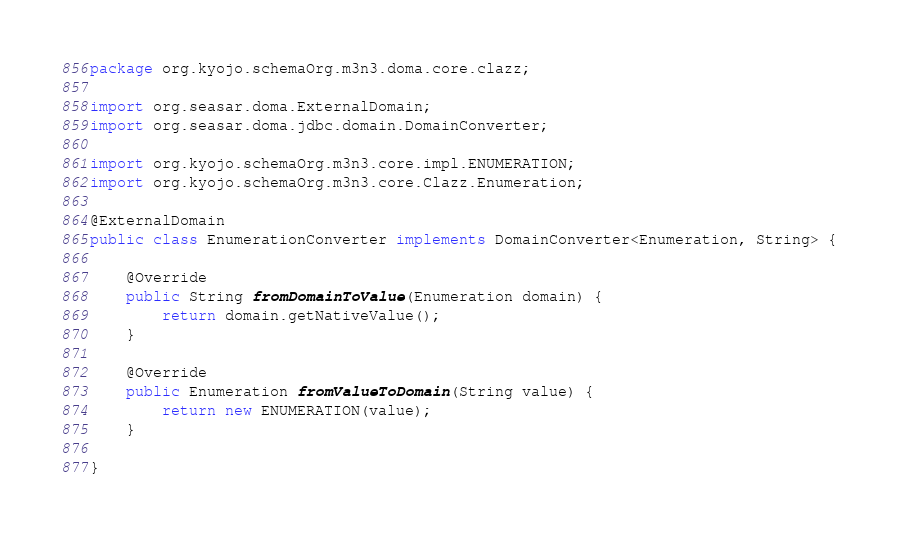<code> <loc_0><loc_0><loc_500><loc_500><_Java_>package org.kyojo.schemaOrg.m3n3.doma.core.clazz;

import org.seasar.doma.ExternalDomain;
import org.seasar.doma.jdbc.domain.DomainConverter;

import org.kyojo.schemaOrg.m3n3.core.impl.ENUMERATION;
import org.kyojo.schemaOrg.m3n3.core.Clazz.Enumeration;

@ExternalDomain
public class EnumerationConverter implements DomainConverter<Enumeration, String> {

	@Override
	public String fromDomainToValue(Enumeration domain) {
		return domain.getNativeValue();
	}

	@Override
	public Enumeration fromValueToDomain(String value) {
		return new ENUMERATION(value);
	}

}
</code> 